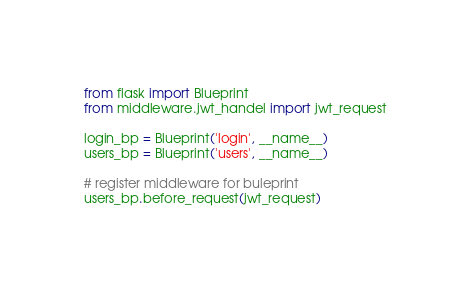Convert code to text. <code><loc_0><loc_0><loc_500><loc_500><_Python_>from flask import Blueprint
from middleware.jwt_handel import jwt_request

login_bp = Blueprint('login', __name__)
users_bp = Blueprint('users', __name__)

# register middleware for buleprint
users_bp.before_request(jwt_request)
</code> 